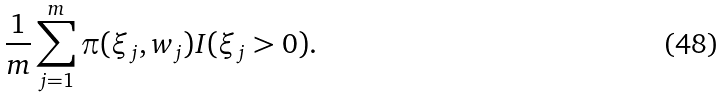Convert formula to latex. <formula><loc_0><loc_0><loc_500><loc_500>\frac { 1 } { m } \sum _ { j = 1 } ^ { m } \pi ( \xi _ { j } , w _ { j } ) I ( \xi _ { j } > 0 ) .</formula> 